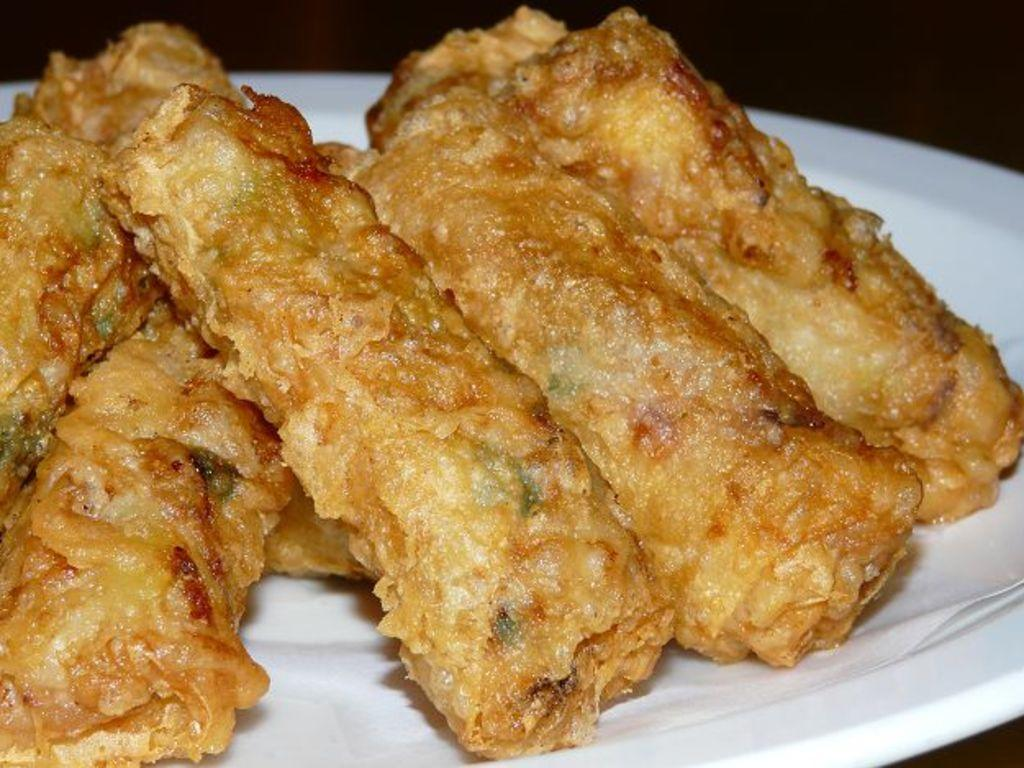What is present on the plate in the image? There is food on the plate in the image. Can you describe the plate in the image? The plate is visible in the image, but no specific details about its appearance are provided. What type of error can be seen on the top of the plate in the image? There is no error visible on the plate in the image, as the provided facts only mention the presence of a plate and food on it. 